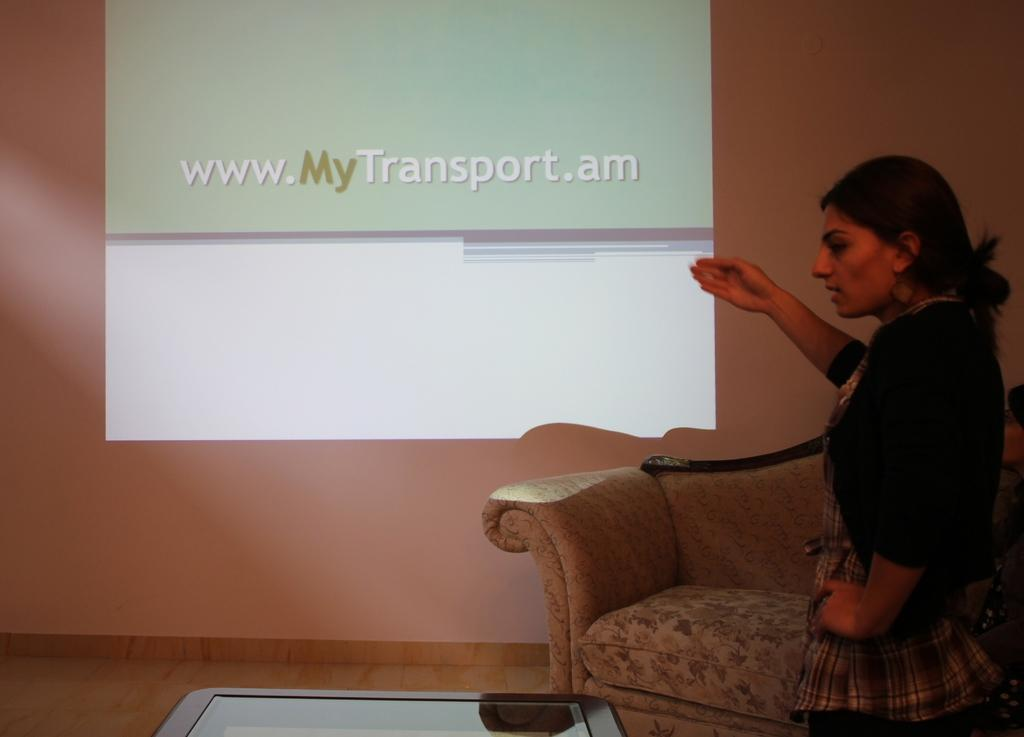Who is present in the image? There is a woman in the image. What type of furniture can be seen in the image? There is a sofa and a table in the image. What is visible in the background of the image? There is a wall and a screen in the background of the image. What type of yarn is being used to measure the distance between the sofa and the screen in the image? There is no yarn or measuring activity present in the image. 